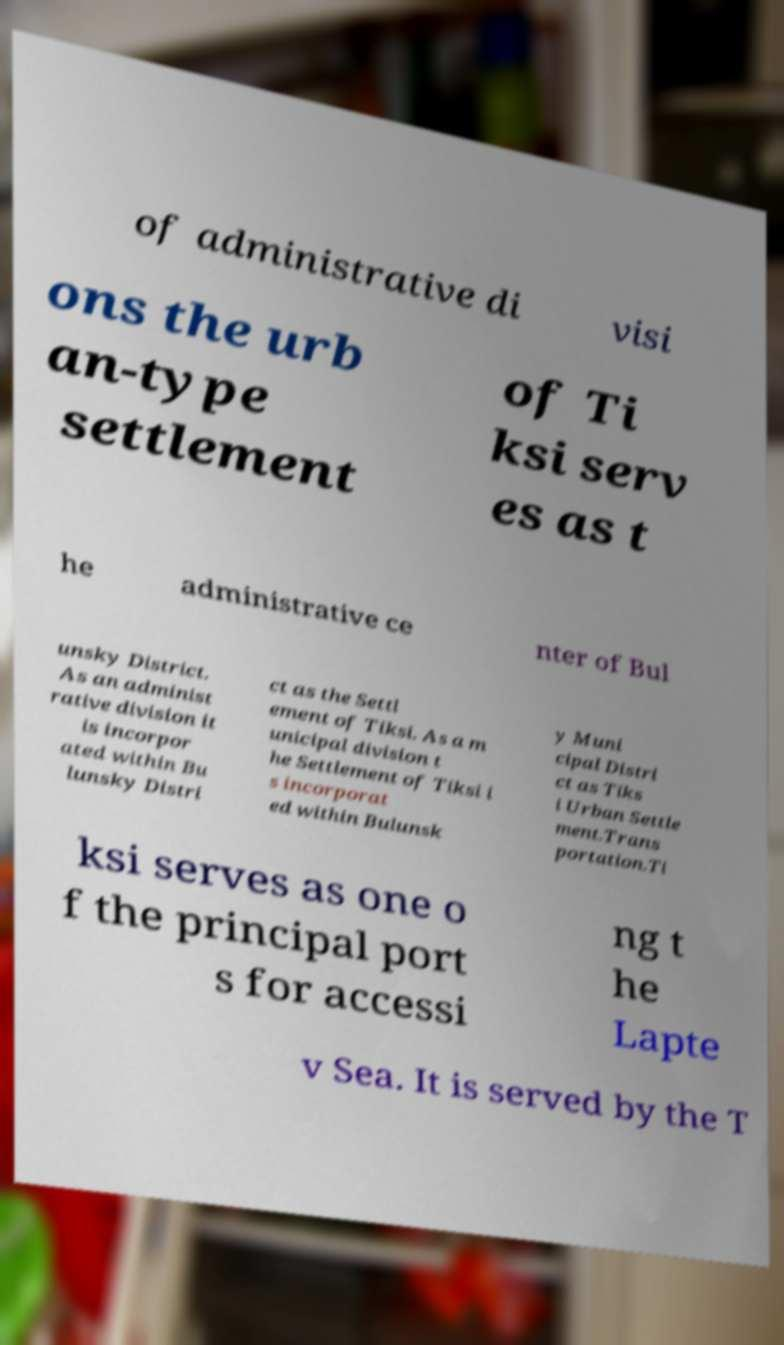Could you assist in decoding the text presented in this image and type it out clearly? of administrative di visi ons the urb an-type settlement of Ti ksi serv es as t he administrative ce nter of Bul unsky District. As an administ rative division it is incorpor ated within Bu lunsky Distri ct as the Settl ement of Tiksi. As a m unicipal division t he Settlement of Tiksi i s incorporat ed within Bulunsk y Muni cipal Distri ct as Tiks i Urban Settle ment.Trans portation.Ti ksi serves as one o f the principal port s for accessi ng t he Lapte v Sea. It is served by the T 